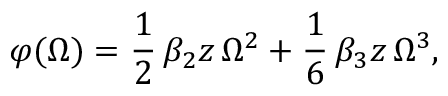Convert formula to latex. <formula><loc_0><loc_0><loc_500><loc_500>\varphi ( \Omega ) = \frac { 1 } { 2 } \, \beta _ { 2 } z \, \Omega ^ { 2 } + \frac { 1 } { 6 } \, \beta _ { 3 } z \, \Omega ^ { 3 } ,</formula> 